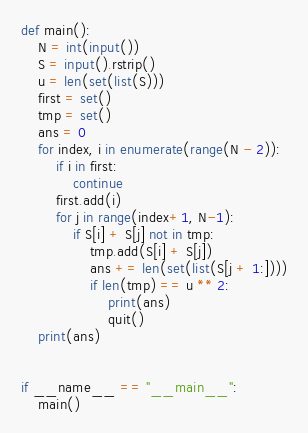Convert code to text. <code><loc_0><loc_0><loc_500><loc_500><_Python_>def main():
    N = int(input())
    S = input().rstrip()
    u = len(set(list(S)))
    first = set()
    tmp = set()
    ans = 0
    for index, i in enumerate(range(N - 2)):
        if i in first:
            continue
        first.add(i)
        for j in range(index+1, N-1):
            if S[i] + S[j] not in tmp:
                tmp.add(S[i] + S[j])
                ans += len(set(list(S[j + 1:])))
                if len(tmp) == u ** 2:
                    print(ans)
                    quit()
    print(ans)


if __name__ == "__main__":
    main()</code> 